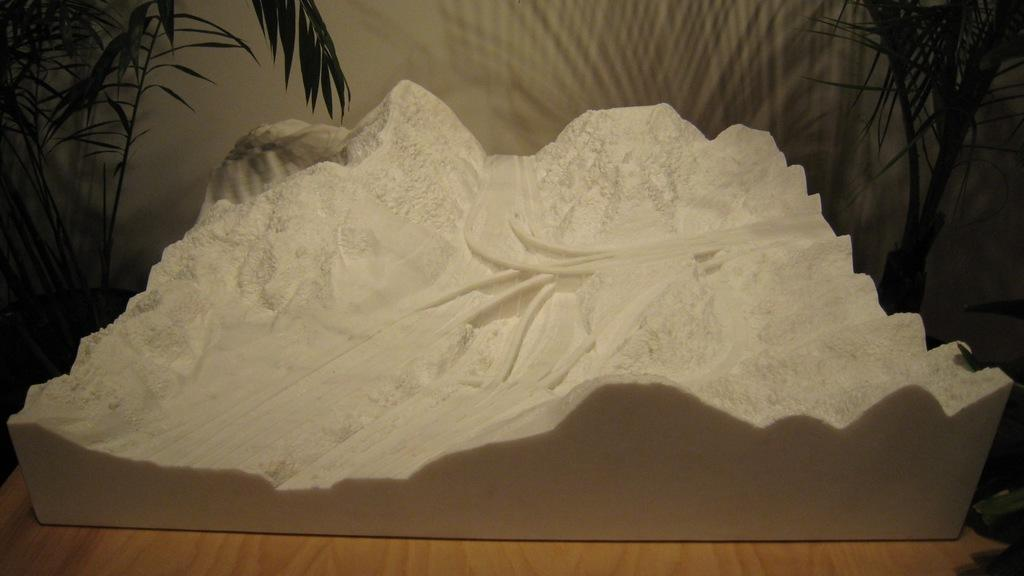What is the main subject of the image? The main subject of the image is a model of ice mountains. Where is the model located in the image? The model is placed on a table. What time does the clock on the ice mountain show in the image? There is no clock present on the ice mountain in the image. 